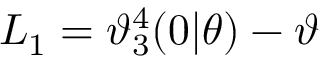<formula> <loc_0><loc_0><loc_500><loc_500>L _ { 1 } = \mathcal { \vartheta } _ { 3 } ^ { 4 } ( 0 | \theta ) - \mathcal { \vartheta }</formula> 